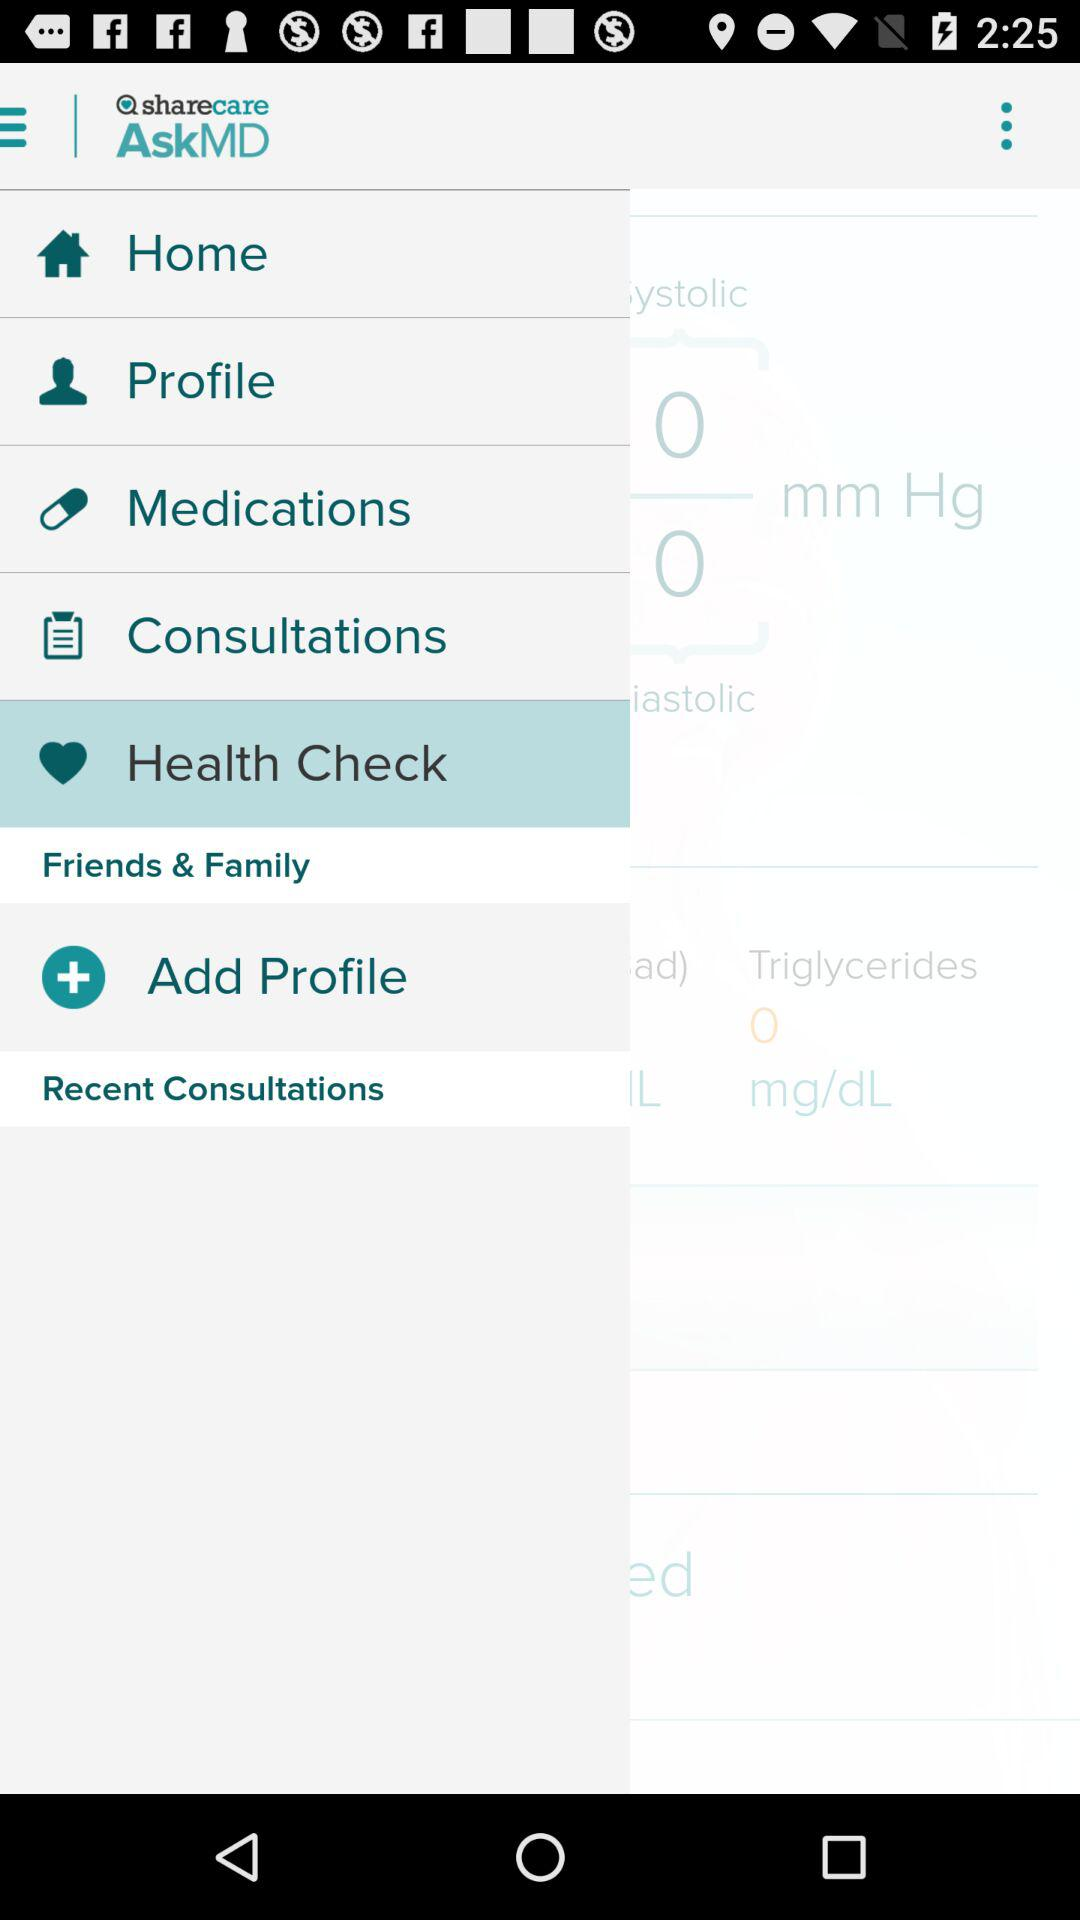Which option is selected? The selected option is "Health Check". 